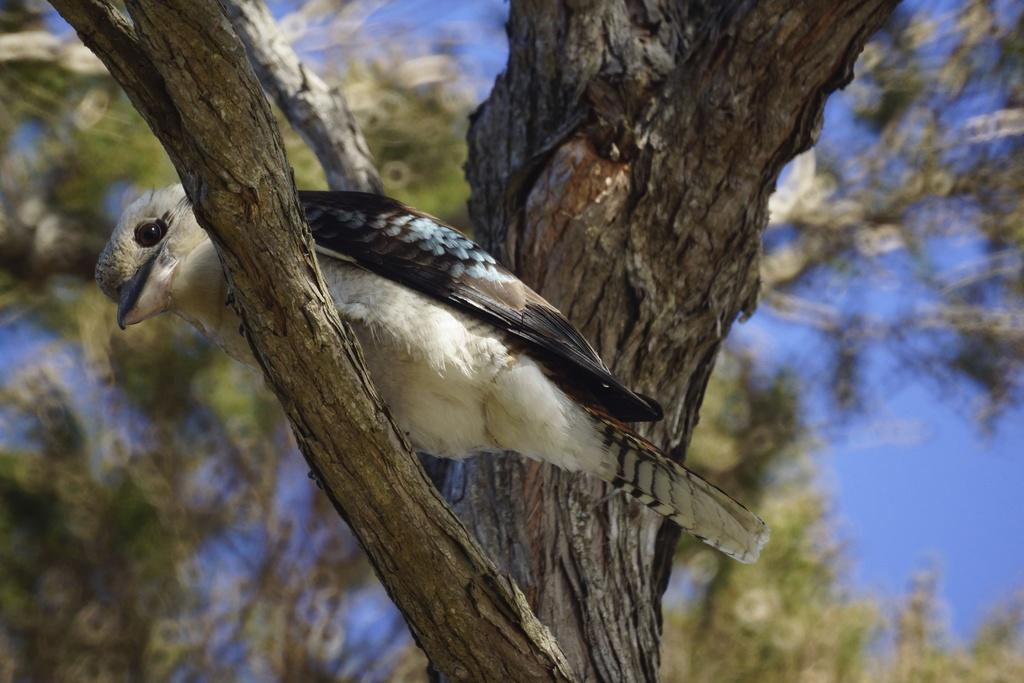How would you summarize this image in a sentence or two? In this image we can see a bird on the branch of a tree. In the background it is blurry and we can see branches of trees and sky. 